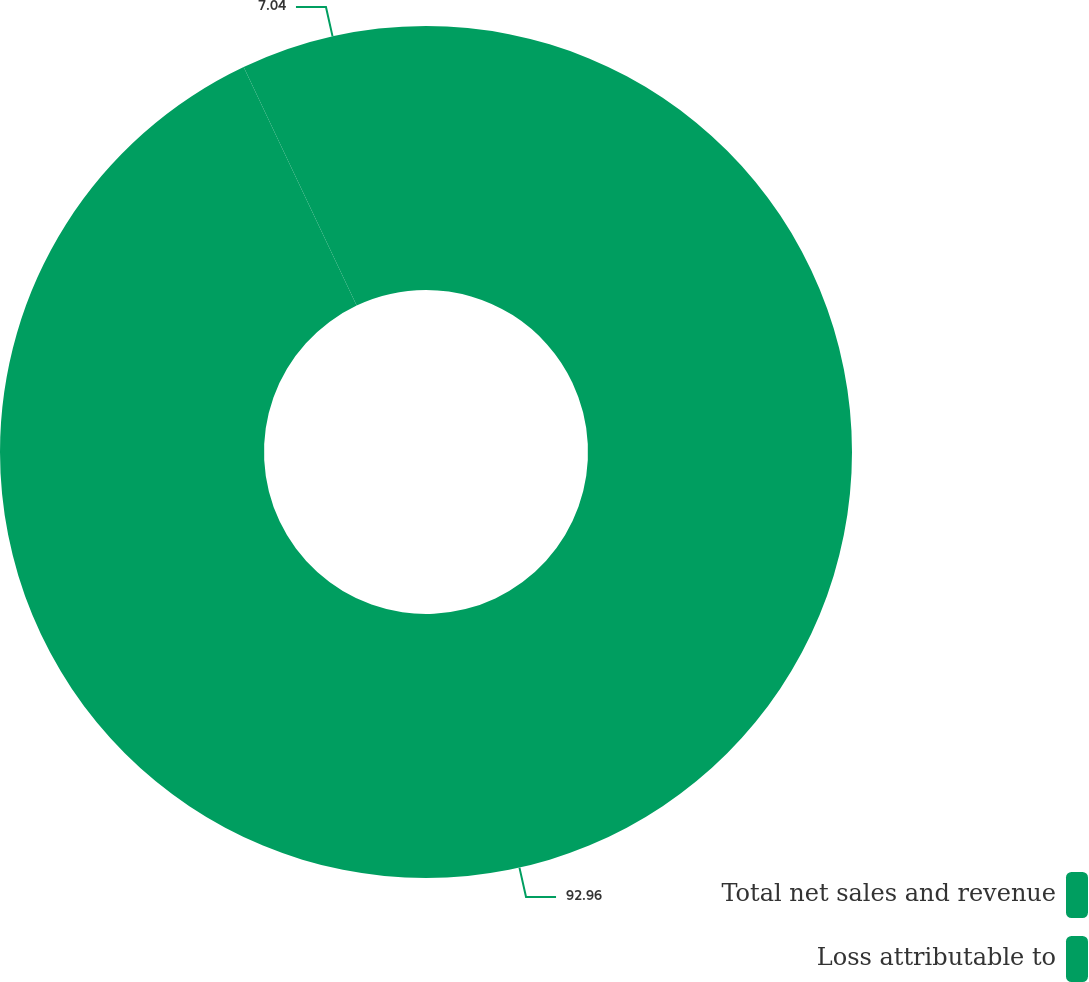Convert chart to OTSL. <chart><loc_0><loc_0><loc_500><loc_500><pie_chart><fcel>Total net sales and revenue<fcel>Loss attributable to<nl><fcel>92.96%<fcel>7.04%<nl></chart> 